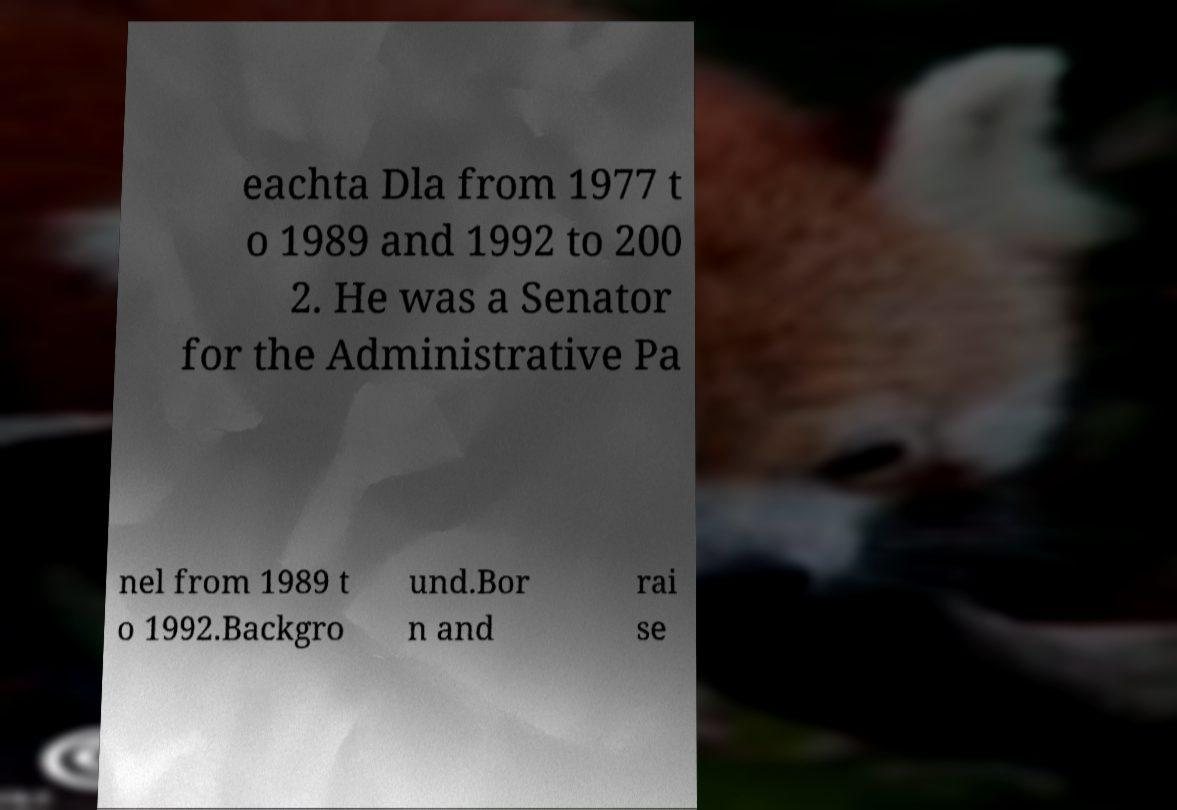What messages or text are displayed in this image? I need them in a readable, typed format. eachta Dla from 1977 t o 1989 and 1992 to 200 2. He was a Senator for the Administrative Pa nel from 1989 t o 1992.Backgro und.Bor n and rai se 